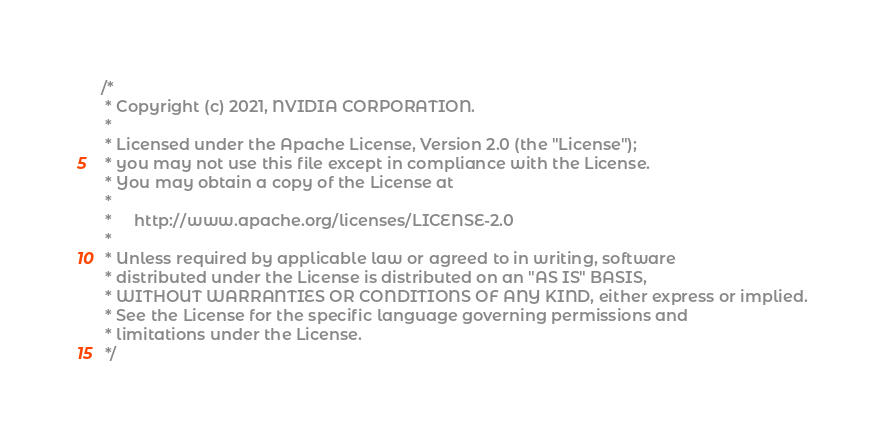Convert code to text. <code><loc_0><loc_0><loc_500><loc_500><_Scala_>/*
 * Copyright (c) 2021, NVIDIA CORPORATION.
 *
 * Licensed under the Apache License, Version 2.0 (the "License");
 * you may not use this file except in compliance with the License.
 * You may obtain a copy of the License at
 *
 *     http://www.apache.org/licenses/LICENSE-2.0
 *
 * Unless required by applicable law or agreed to in writing, software
 * distributed under the License is distributed on an "AS IS" BASIS,
 * WITHOUT WARRANTIES OR CONDITIONS OF ANY KIND, either express or implied.
 * See the License for the specific language governing permissions and
 * limitations under the License.
 */
</code> 